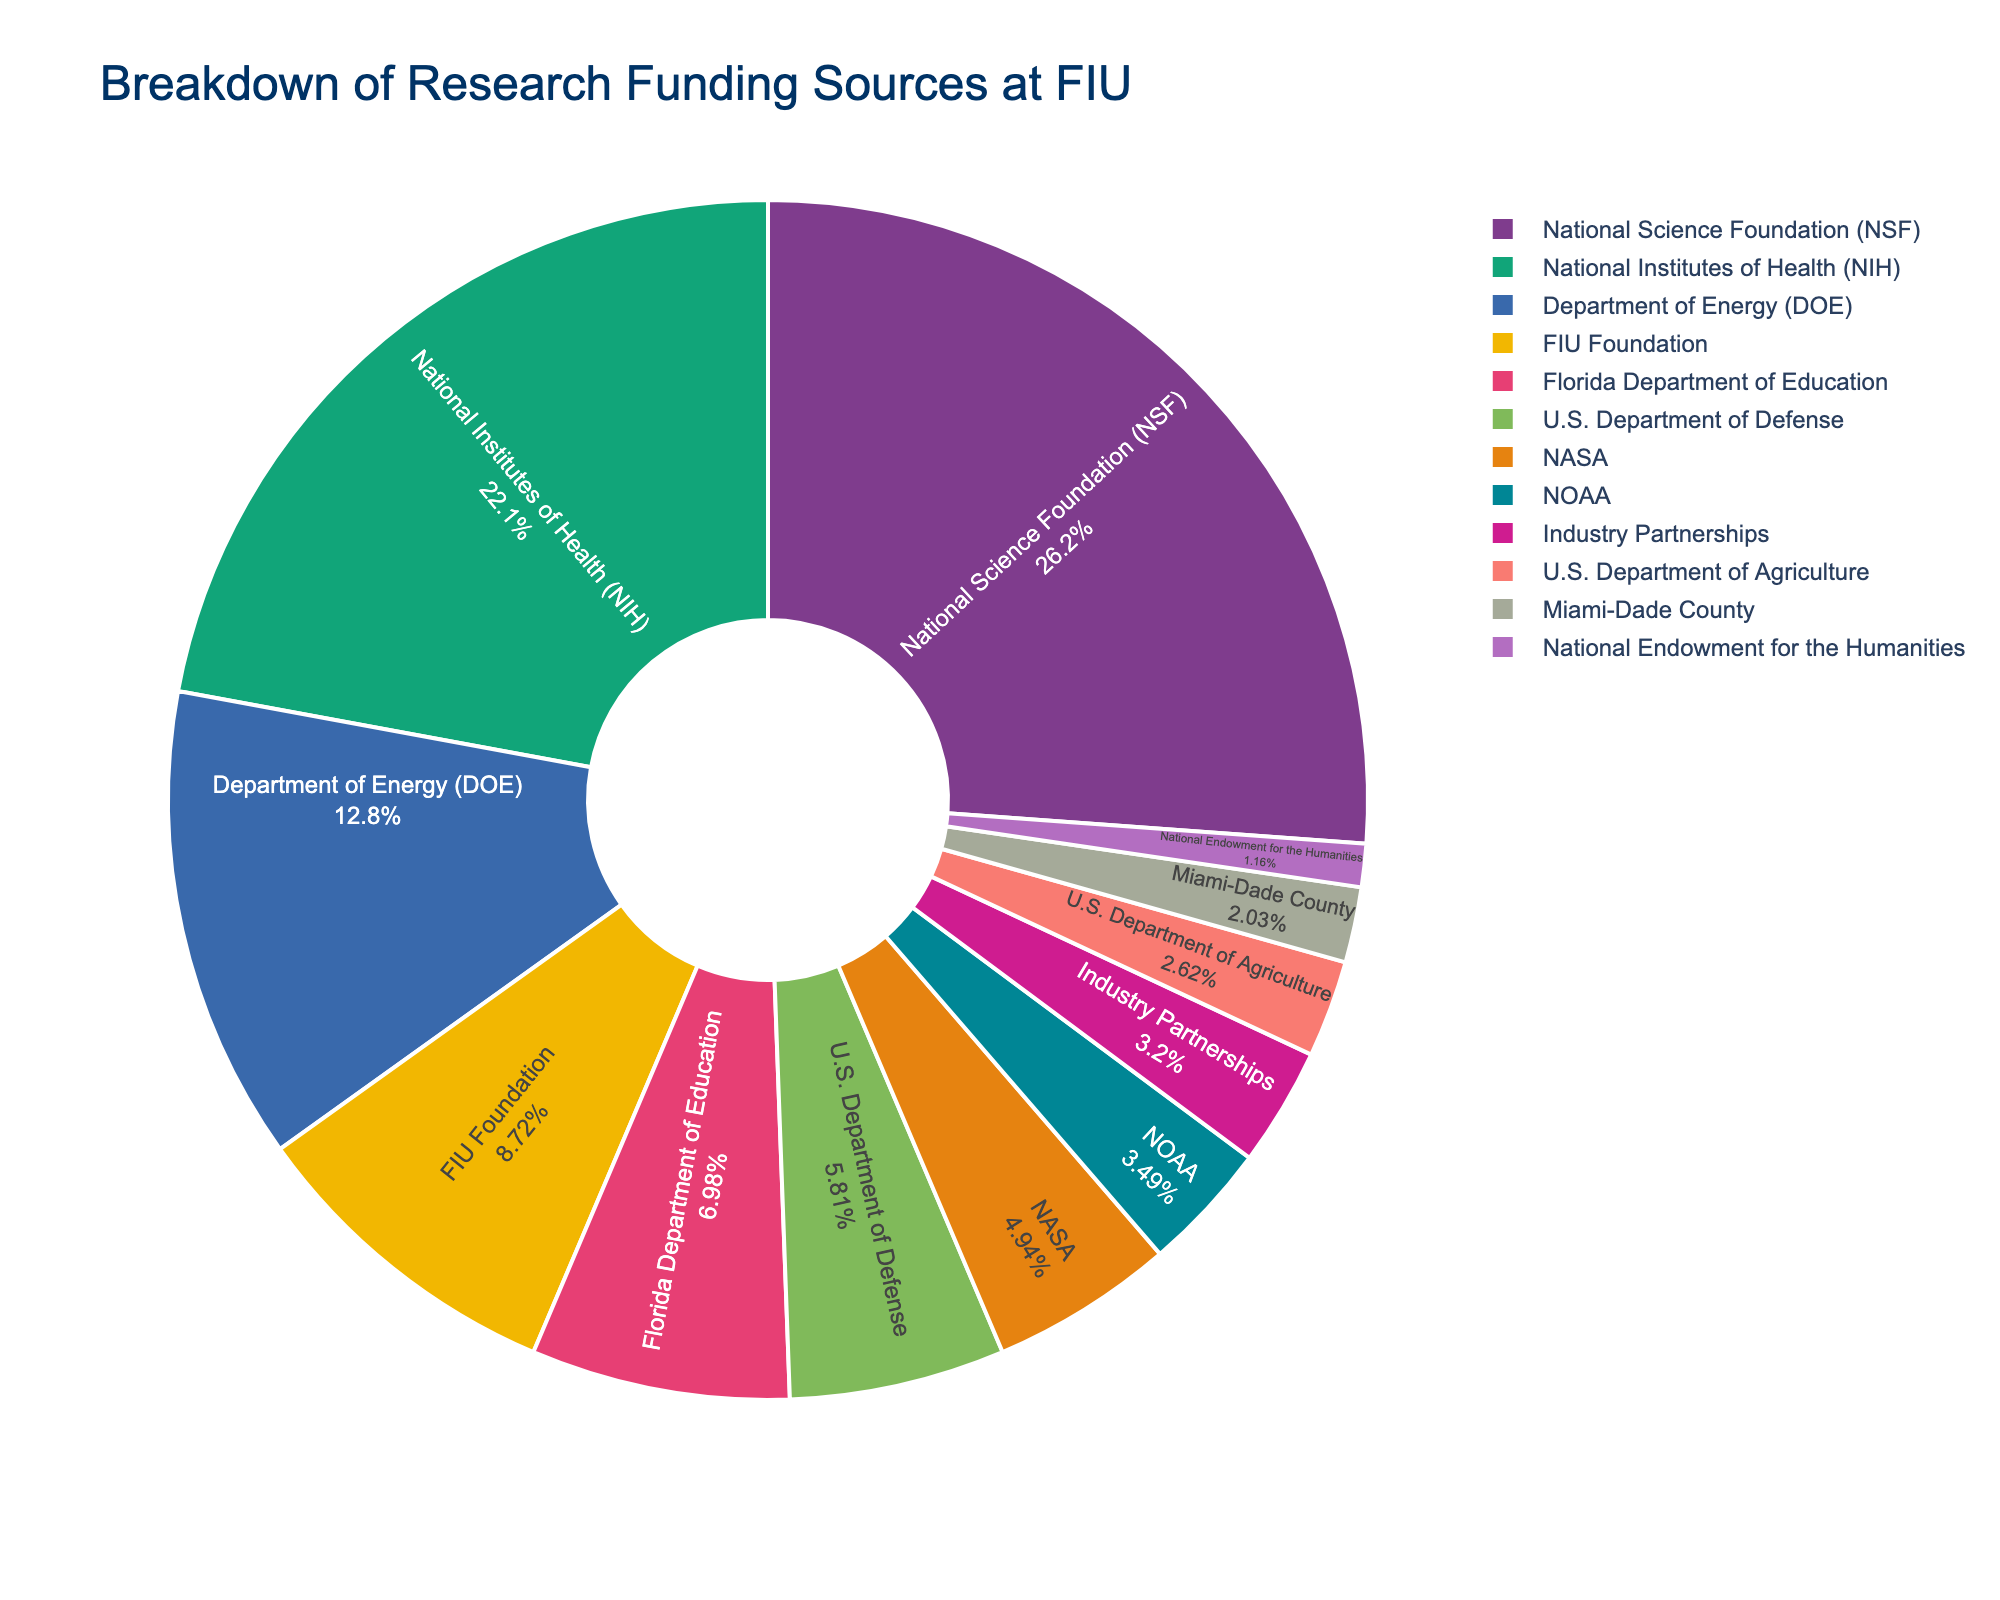Which funding source contributes the largest percentage to FIU's research funding? The pie chart clearly shows that the segment for the National Science Foundation (NSF) is the largest among all segments, indicating it has the highest percentage share.
Answer: National Science Foundation (NSF) How much more funding does NSF provide compared to the NIH? To find the difference, subtract the NIH's funding amount from the NSF's. NSF provides $45,000,000 and NIH provides $38,000,000. So, $45,000,000 - $38,000,000 = $7,000,000
Answer: $7,000,000 What is the combined funding amount from the DOE, FIU Foundation, and NASA? Sum the funding amounts from these three sources: DOE ($22,000,000) + FIU Foundation ($15,000,000) + NASA ($8,500,000). Adding these gives $22,000,000 + $15,000,000 + $8,500,000 = $45,500,000
Answer: $45,500,000 Which two funding sources have the smallest contributions and what is their combined amount? The two smallest segments on the pie chart represent Miami-Dade County ($3,500,000) and the National Endowment for the Humanities ($2,000,000). Their combined amount is $3,500,000 + $2,000,000 = $5,500,000
Answer: Miami-Dade County and National Endowment for the Humanities; $5,500,000 Is the funding from the Department of Energy (DOE) greater than the combined funding from Industry Partnerships and the U.S. Department of Agriculture? First, sum the amounts for Industry Partnerships ($5,500,000) and U.S. Department of Agriculture ($4,500,000), which is $5,500,000 + $4,500,000 = $10,000,000. Since the DOE funding amount is $22,000,000, it is indeed greater than $10,000,000.
Answer: Yes What percentage of the total research funding does the Florida Department of Education contribute? First, sum all the funding amounts to get the total. The total is $145,000,000. The Florida Department of Education contributes $12,000,000. The percentage is calculated as ($12,000,000 / $145,000,000) * 100 = 8.28%
Answer: Approximately 8.28% Which funding source is represented by a segment that is visually similar in size to that of NASA? By visual inspection, the segment for the U.S. Department of Defense appears similar in size to NASA's. Both segments are relatively smaller but not the smallest on the chart.
Answer: U.S. Department of Defense How do the combined contributions from federal agencies (NSF, NIH, DOE, U.S. Department of Defense, NASA, NOAA, U.S. Department of Agriculture) compare against those from state and local funding (FIU Foundation, Florida Department of Education, Miami-Dade County)? First, sum the federal agencies' amounts: NSF ($45,000,000) + NIH ($38,000,000) + DOE ($22,000,000) + U.S. Department of Defense ($10,000,000) + NASA ($8,500,000) + NOAA ($6,000,000) + U.S. Department of Agriculture ($4,500,000) = $134,000,000. Then, sum the state and local amounts: FIU Foundation ($15,000,000) + Florida Department of Education ($12,000,000) + Miami-Dade County ($3,500,000) = $30,500,000. Federal agencies contribute much more ($134,000,000 vs $30,500,000).
Answer: Federal agencies contribute more 